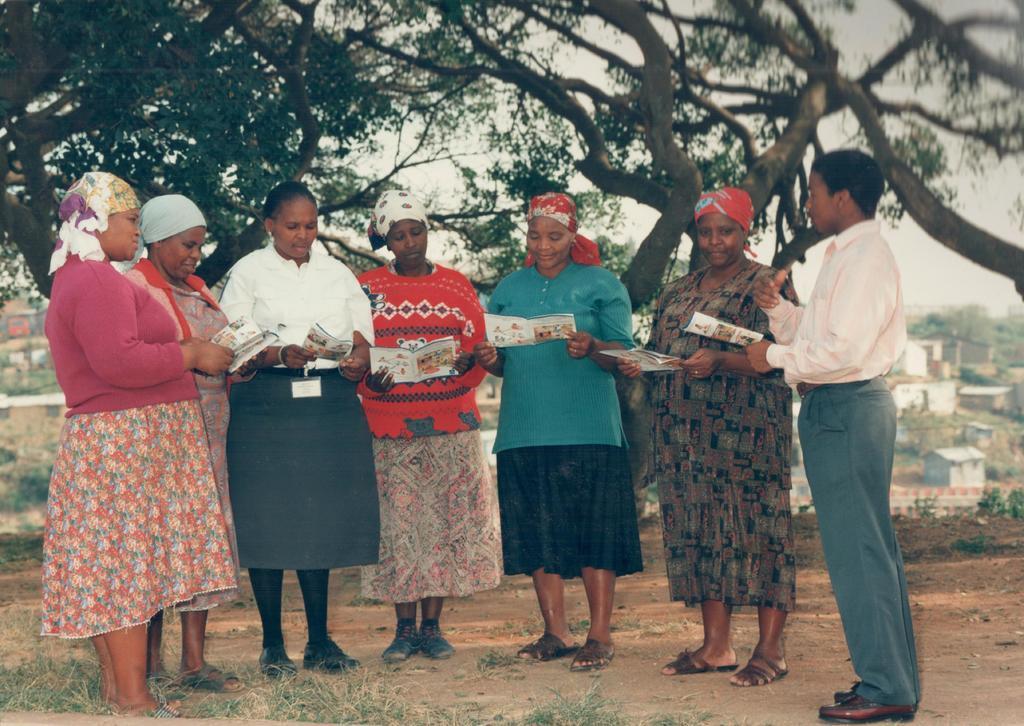Can you describe this image briefly? Front these group of people are holding papers and standing. Background there are houses and trees. 